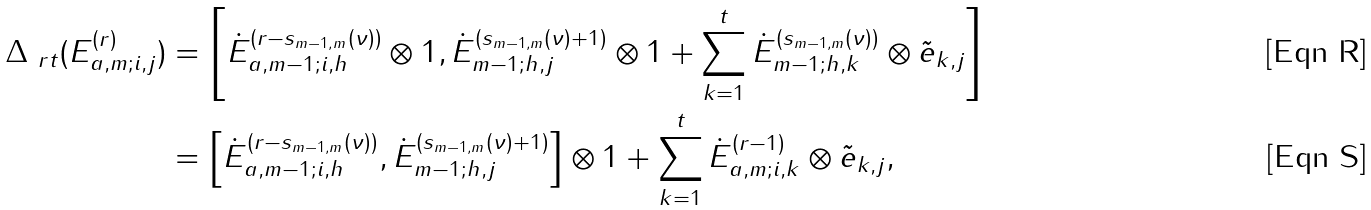Convert formula to latex. <formula><loc_0><loc_0><loc_500><loc_500>\Delta _ { \ r t } ( E _ { a , m ; i , j } ^ { ( r ) } ) & = \left [ \dot { E } _ { a , m - 1 ; i , h } ^ { ( r - s _ { m - 1 , m } ( \nu ) ) } \otimes 1 , \dot { E } _ { m - 1 ; h , j } ^ { ( s _ { m - 1 , m } ( \nu ) + 1 ) } \otimes 1 + \sum _ { k = 1 } ^ { t } \dot { E } _ { m - 1 ; h , k } ^ { ( s _ { m - 1 , m } ( \nu ) ) } \otimes \tilde { e } _ { k , j } \right ] \\ & = \left [ \dot { E } _ { a , m - 1 ; i , h } ^ { ( r - s _ { m - 1 , m } ( \nu ) ) } , \dot { E } _ { m - 1 ; h , j } ^ { ( s _ { m - 1 , m } ( \nu ) + 1 ) } \right ] \otimes 1 + \sum _ { k = 1 } ^ { t } \dot { E } _ { a , m ; i , k } ^ { ( r - 1 ) } \otimes \tilde { e } _ { k , j } ,</formula> 